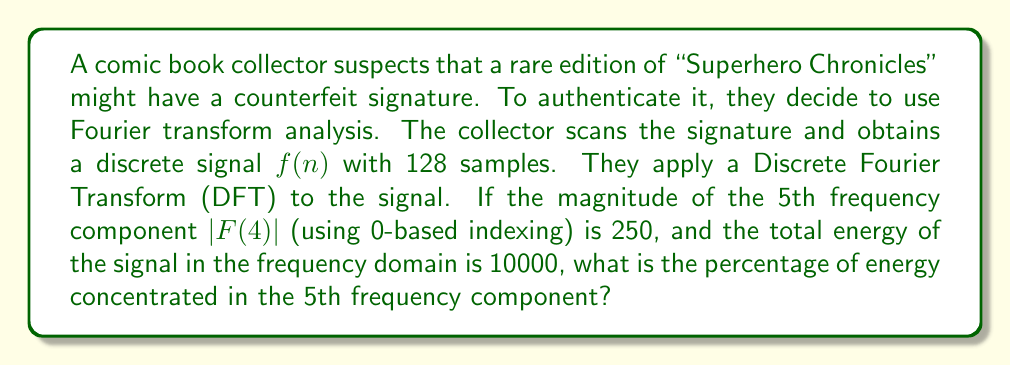Could you help me with this problem? To solve this problem, we need to follow these steps:

1) Recall that the Discrete Fourier Transform (DFT) of a signal $f(n)$ is given by:

   $$F(k) = \sum_{n=0}^{N-1} f(n) e^{-j2\pi kn/N}$$

   where $N$ is the number of samples (128 in this case).

2) The energy of a discrete signal in the frequency domain is given by Parseval's theorem:

   $$\sum_{n=0}^{N-1} |f(n)|^2 = \frac{1}{N} \sum_{k=0}^{N-1} |F(k)|^2$$

3) We're given that the total energy in the frequency domain is 10000, so:

   $$\sum_{k=0}^{N-1} |F(k)|^2 = 10000N = 10000 * 128 = 1280000$$

4) We're also given that $|F(4)| = 250$. The energy in this frequency component is $|F(4)|^2 = 250^2 = 62500$.

5) To find the percentage of energy in this component, we divide its energy by the total energy and multiply by 100:

   $$\text{Percentage} = \frac{|F(4)|^2}{\sum_{k=0}^{N-1} |F(k)|^2} * 100 = \frac{62500}{1280000} * 100 \approx 4.8828125\%$$

This percentage represents the proportion of the signature's energy concentrated at this specific frequency, which can be used as part of the analysis to determine the authenticity of the signature.
Answer: The percentage of energy concentrated in the 5th frequency component is approximately 4.8828125%. 